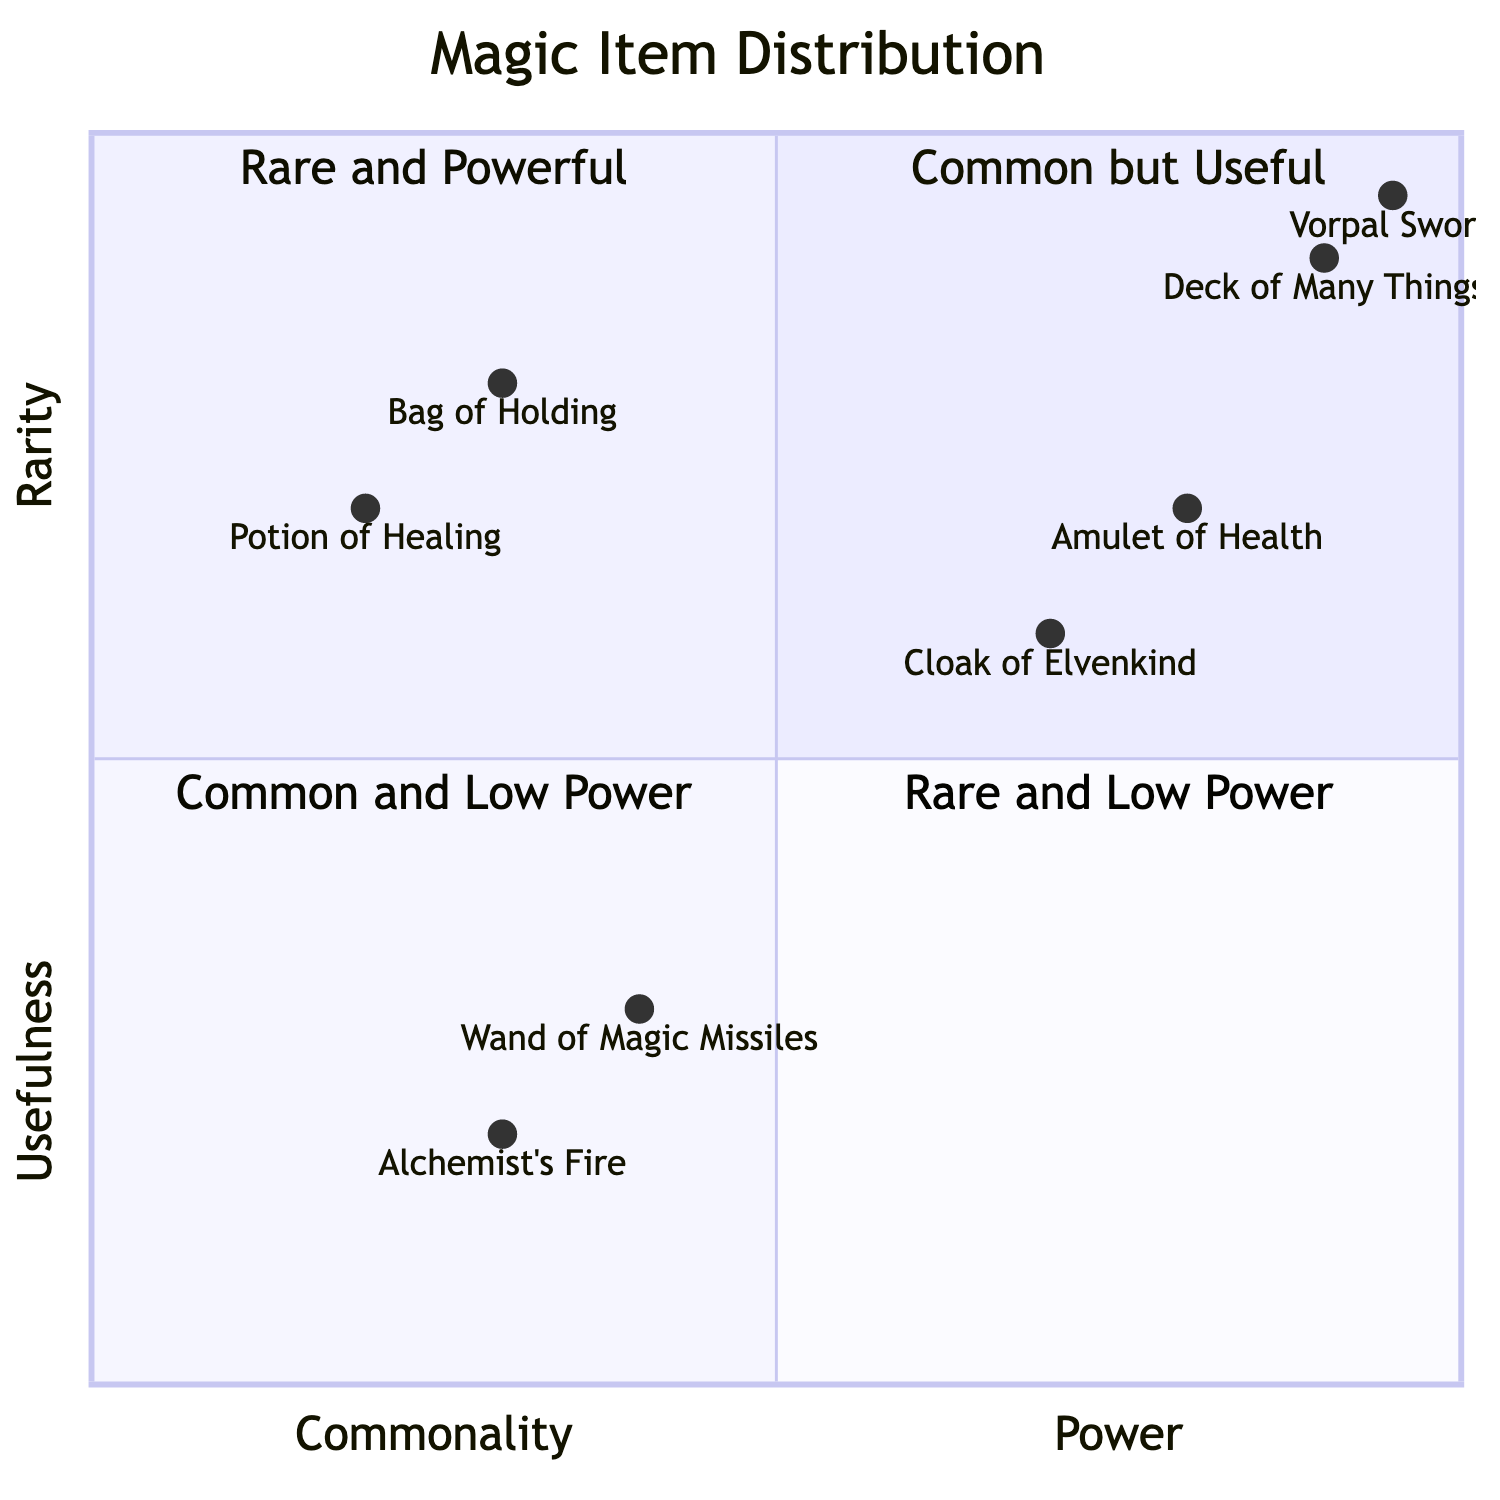What is the most powerful magic item in the diagram? To find the most powerful item, I look at the top-right quadrant, which represents Rare and Powerful items. In this quadrant, both the Deck of Many Things and the Vorpal Sword are present, but the Vorpal Sword is positioned higher up, indicating it is more powerful than the Deck of Many Things.
Answer: Vorpal Sword How many items are categorized as Common? Counting the items in the left half of the diagram, which represents Common items, I see that there are three items: Potion of Healing, Bag of Holding, and Wand of Magic Missiles.
Answer: 3 Which item is both Common and Useful? I need to look in the top-left quadrant, which indicates items that are Common but Useful. The two items in this category are the Potion of Healing and the Bag of Holding. However, the focus is on any one item; I can choose either, but typically the first one listed is used as the answer.
Answer: Potion of Healing Which item is the least useful in the diagram? The least useful item is found in the bottom-left quadrant, which contains items that are both Common and Low Power. In this case, Alchemist's Fire is the lowest on the y-axis, indicating it has the least usefulness compared to others.
Answer: Alchemist's Fire What is the relationship between the Wand of Magic Missiles and Alchemist's Fire in terms of power? Both the Wand of Magic Missiles and Alchemist's Fire are found in the bottom quadrants, with Alchemist's Fire in the bottom-left and Wand of Magic Missiles in the bottom-right. They are categorized similarly as Common items but Alchemist's Fire is categorized as Low Power more explicitly than the Wand of Magic Missiles.
Answer: Alchemist's Fire is lower 